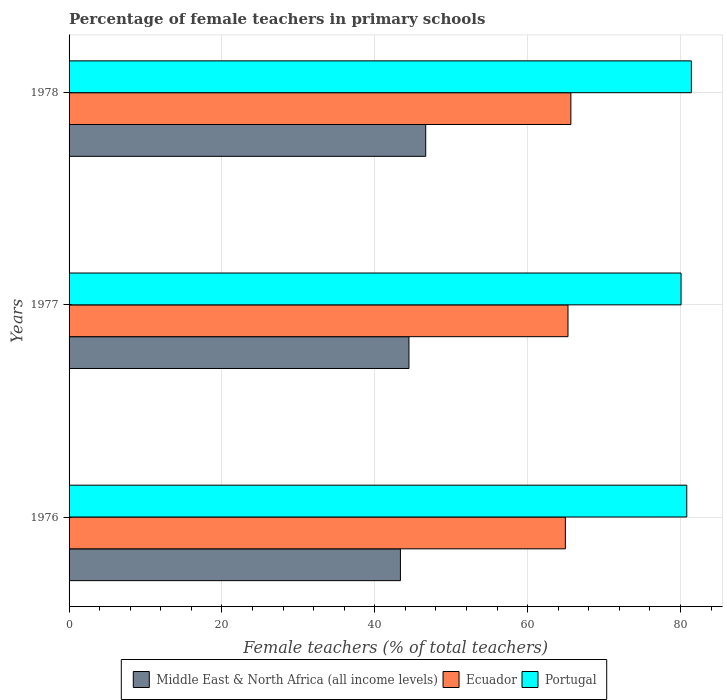How many different coloured bars are there?
Give a very brief answer. 3. Are the number of bars on each tick of the Y-axis equal?
Give a very brief answer. Yes. How many bars are there on the 3rd tick from the top?
Keep it short and to the point. 3. What is the label of the 2nd group of bars from the top?
Your answer should be compact. 1977. In how many cases, is the number of bars for a given year not equal to the number of legend labels?
Your response must be concise. 0. What is the percentage of female teachers in Portugal in 1976?
Keep it short and to the point. 80.82. Across all years, what is the maximum percentage of female teachers in Portugal?
Make the answer very short. 81.42. Across all years, what is the minimum percentage of female teachers in Portugal?
Your response must be concise. 80.07. In which year was the percentage of female teachers in Ecuador maximum?
Your answer should be compact. 1978. In which year was the percentage of female teachers in Ecuador minimum?
Provide a succinct answer. 1976. What is the total percentage of female teachers in Middle East & North Africa (all income levels) in the graph?
Provide a short and direct response. 134.49. What is the difference between the percentage of female teachers in Ecuador in 1976 and that in 1978?
Keep it short and to the point. -0.72. What is the difference between the percentage of female teachers in Ecuador in 1978 and the percentage of female teachers in Middle East & North Africa (all income levels) in 1977?
Make the answer very short. 21.19. What is the average percentage of female teachers in Middle East & North Africa (all income levels) per year?
Your answer should be compact. 44.83. In the year 1977, what is the difference between the percentage of female teachers in Ecuador and percentage of female teachers in Middle East & North Africa (all income levels)?
Offer a terse response. 20.81. In how many years, is the percentage of female teachers in Middle East & North Africa (all income levels) greater than 44 %?
Provide a succinct answer. 2. What is the ratio of the percentage of female teachers in Ecuador in 1976 to that in 1977?
Offer a very short reply. 0.99. What is the difference between the highest and the second highest percentage of female teachers in Ecuador?
Ensure brevity in your answer.  0.38. What is the difference between the highest and the lowest percentage of female teachers in Middle East & North Africa (all income levels)?
Provide a short and direct response. 3.31. In how many years, is the percentage of female teachers in Portugal greater than the average percentage of female teachers in Portugal taken over all years?
Give a very brief answer. 2. What does the 1st bar from the top in 1976 represents?
Your answer should be compact. Portugal. What does the 3rd bar from the bottom in 1976 represents?
Your answer should be very brief. Portugal. How many years are there in the graph?
Offer a terse response. 3. What is the difference between two consecutive major ticks on the X-axis?
Your response must be concise. 20. Does the graph contain grids?
Provide a short and direct response. Yes. How many legend labels are there?
Keep it short and to the point. 3. What is the title of the graph?
Your answer should be very brief. Percentage of female teachers in primary schools. Does "Namibia" appear as one of the legend labels in the graph?
Provide a succinct answer. No. What is the label or title of the X-axis?
Provide a short and direct response. Female teachers (% of total teachers). What is the Female teachers (% of total teachers) of Middle East & North Africa (all income levels) in 1976?
Provide a succinct answer. 43.35. What is the Female teachers (% of total teachers) in Ecuador in 1976?
Ensure brevity in your answer.  64.93. What is the Female teachers (% of total teachers) of Portugal in 1976?
Offer a very short reply. 80.82. What is the Female teachers (% of total teachers) in Middle East & North Africa (all income levels) in 1977?
Give a very brief answer. 44.47. What is the Female teachers (% of total teachers) of Ecuador in 1977?
Your answer should be compact. 65.28. What is the Female teachers (% of total teachers) of Portugal in 1977?
Ensure brevity in your answer.  80.07. What is the Female teachers (% of total teachers) in Middle East & North Africa (all income levels) in 1978?
Make the answer very short. 46.66. What is the Female teachers (% of total teachers) of Ecuador in 1978?
Provide a succinct answer. 65.66. What is the Female teachers (% of total teachers) of Portugal in 1978?
Offer a terse response. 81.42. Across all years, what is the maximum Female teachers (% of total teachers) in Middle East & North Africa (all income levels)?
Give a very brief answer. 46.66. Across all years, what is the maximum Female teachers (% of total teachers) of Ecuador?
Your answer should be very brief. 65.66. Across all years, what is the maximum Female teachers (% of total teachers) in Portugal?
Make the answer very short. 81.42. Across all years, what is the minimum Female teachers (% of total teachers) in Middle East & North Africa (all income levels)?
Provide a short and direct response. 43.35. Across all years, what is the minimum Female teachers (% of total teachers) of Ecuador?
Your answer should be compact. 64.93. Across all years, what is the minimum Female teachers (% of total teachers) in Portugal?
Your response must be concise. 80.07. What is the total Female teachers (% of total teachers) in Middle East & North Africa (all income levels) in the graph?
Your answer should be compact. 134.49. What is the total Female teachers (% of total teachers) in Ecuador in the graph?
Offer a terse response. 195.87. What is the total Female teachers (% of total teachers) in Portugal in the graph?
Give a very brief answer. 242.31. What is the difference between the Female teachers (% of total teachers) of Middle East & North Africa (all income levels) in 1976 and that in 1977?
Provide a succinct answer. -1.12. What is the difference between the Female teachers (% of total teachers) of Ecuador in 1976 and that in 1977?
Your response must be concise. -0.35. What is the difference between the Female teachers (% of total teachers) of Portugal in 1976 and that in 1977?
Offer a terse response. 0.75. What is the difference between the Female teachers (% of total teachers) of Middle East & North Africa (all income levels) in 1976 and that in 1978?
Ensure brevity in your answer.  -3.31. What is the difference between the Female teachers (% of total teachers) of Ecuador in 1976 and that in 1978?
Give a very brief answer. -0.72. What is the difference between the Female teachers (% of total teachers) in Portugal in 1976 and that in 1978?
Your response must be concise. -0.6. What is the difference between the Female teachers (% of total teachers) in Middle East & North Africa (all income levels) in 1977 and that in 1978?
Your answer should be very brief. -2.19. What is the difference between the Female teachers (% of total teachers) of Ecuador in 1977 and that in 1978?
Ensure brevity in your answer.  -0.38. What is the difference between the Female teachers (% of total teachers) in Portugal in 1977 and that in 1978?
Make the answer very short. -1.35. What is the difference between the Female teachers (% of total teachers) in Middle East & North Africa (all income levels) in 1976 and the Female teachers (% of total teachers) in Ecuador in 1977?
Your answer should be very brief. -21.93. What is the difference between the Female teachers (% of total teachers) of Middle East & North Africa (all income levels) in 1976 and the Female teachers (% of total teachers) of Portugal in 1977?
Make the answer very short. -36.72. What is the difference between the Female teachers (% of total teachers) in Ecuador in 1976 and the Female teachers (% of total teachers) in Portugal in 1977?
Ensure brevity in your answer.  -15.14. What is the difference between the Female teachers (% of total teachers) in Middle East & North Africa (all income levels) in 1976 and the Female teachers (% of total teachers) in Ecuador in 1978?
Your answer should be very brief. -22.3. What is the difference between the Female teachers (% of total teachers) of Middle East & North Africa (all income levels) in 1976 and the Female teachers (% of total teachers) of Portugal in 1978?
Offer a very short reply. -38.07. What is the difference between the Female teachers (% of total teachers) in Ecuador in 1976 and the Female teachers (% of total teachers) in Portugal in 1978?
Give a very brief answer. -16.49. What is the difference between the Female teachers (% of total teachers) in Middle East & North Africa (all income levels) in 1977 and the Female teachers (% of total teachers) in Ecuador in 1978?
Provide a short and direct response. -21.19. What is the difference between the Female teachers (% of total teachers) in Middle East & North Africa (all income levels) in 1977 and the Female teachers (% of total teachers) in Portugal in 1978?
Your response must be concise. -36.95. What is the difference between the Female teachers (% of total teachers) of Ecuador in 1977 and the Female teachers (% of total teachers) of Portugal in 1978?
Offer a very short reply. -16.14. What is the average Female teachers (% of total teachers) in Middle East & North Africa (all income levels) per year?
Make the answer very short. 44.83. What is the average Female teachers (% of total teachers) in Ecuador per year?
Offer a terse response. 65.29. What is the average Female teachers (% of total teachers) of Portugal per year?
Your answer should be very brief. 80.77. In the year 1976, what is the difference between the Female teachers (% of total teachers) of Middle East & North Africa (all income levels) and Female teachers (% of total teachers) of Ecuador?
Offer a very short reply. -21.58. In the year 1976, what is the difference between the Female teachers (% of total teachers) of Middle East & North Africa (all income levels) and Female teachers (% of total teachers) of Portugal?
Your answer should be very brief. -37.46. In the year 1976, what is the difference between the Female teachers (% of total teachers) in Ecuador and Female teachers (% of total teachers) in Portugal?
Keep it short and to the point. -15.88. In the year 1977, what is the difference between the Female teachers (% of total teachers) in Middle East & North Africa (all income levels) and Female teachers (% of total teachers) in Ecuador?
Offer a very short reply. -20.81. In the year 1977, what is the difference between the Female teachers (% of total teachers) of Middle East & North Africa (all income levels) and Female teachers (% of total teachers) of Portugal?
Make the answer very short. -35.6. In the year 1977, what is the difference between the Female teachers (% of total teachers) of Ecuador and Female teachers (% of total teachers) of Portugal?
Your answer should be compact. -14.79. In the year 1978, what is the difference between the Female teachers (% of total teachers) in Middle East & North Africa (all income levels) and Female teachers (% of total teachers) in Ecuador?
Offer a very short reply. -18.99. In the year 1978, what is the difference between the Female teachers (% of total teachers) of Middle East & North Africa (all income levels) and Female teachers (% of total teachers) of Portugal?
Your answer should be very brief. -34.76. In the year 1978, what is the difference between the Female teachers (% of total teachers) of Ecuador and Female teachers (% of total teachers) of Portugal?
Your answer should be very brief. -15.77. What is the ratio of the Female teachers (% of total teachers) in Middle East & North Africa (all income levels) in 1976 to that in 1977?
Provide a succinct answer. 0.97. What is the ratio of the Female teachers (% of total teachers) of Ecuador in 1976 to that in 1977?
Offer a very short reply. 0.99. What is the ratio of the Female teachers (% of total teachers) of Portugal in 1976 to that in 1977?
Offer a very short reply. 1.01. What is the ratio of the Female teachers (% of total teachers) of Middle East & North Africa (all income levels) in 1976 to that in 1978?
Keep it short and to the point. 0.93. What is the ratio of the Female teachers (% of total teachers) in Portugal in 1976 to that in 1978?
Offer a terse response. 0.99. What is the ratio of the Female teachers (% of total teachers) in Middle East & North Africa (all income levels) in 1977 to that in 1978?
Your answer should be compact. 0.95. What is the ratio of the Female teachers (% of total teachers) in Portugal in 1977 to that in 1978?
Give a very brief answer. 0.98. What is the difference between the highest and the second highest Female teachers (% of total teachers) of Middle East & North Africa (all income levels)?
Provide a succinct answer. 2.19. What is the difference between the highest and the second highest Female teachers (% of total teachers) in Ecuador?
Ensure brevity in your answer.  0.38. What is the difference between the highest and the second highest Female teachers (% of total teachers) in Portugal?
Ensure brevity in your answer.  0.6. What is the difference between the highest and the lowest Female teachers (% of total teachers) of Middle East & North Africa (all income levels)?
Your answer should be very brief. 3.31. What is the difference between the highest and the lowest Female teachers (% of total teachers) of Ecuador?
Provide a short and direct response. 0.72. What is the difference between the highest and the lowest Female teachers (% of total teachers) of Portugal?
Provide a succinct answer. 1.35. 